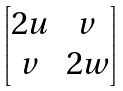<formula> <loc_0><loc_0><loc_500><loc_500>\begin{bmatrix} 2 u & v \\ v & 2 w \end{bmatrix}</formula> 